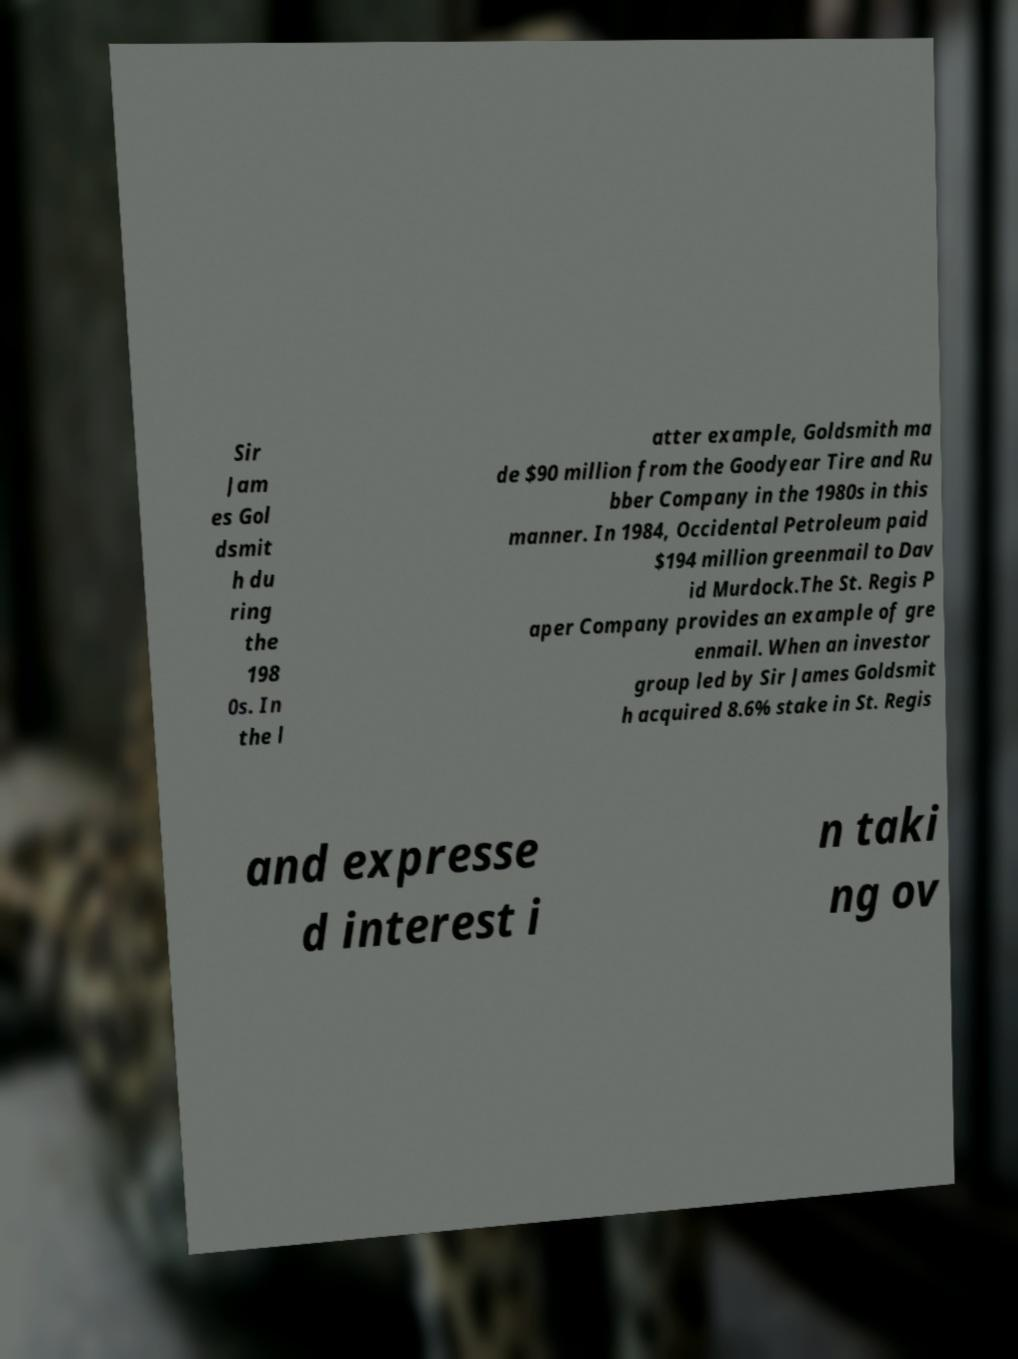Could you extract and type out the text from this image? Sir Jam es Gol dsmit h du ring the 198 0s. In the l atter example, Goldsmith ma de $90 million from the Goodyear Tire and Ru bber Company in the 1980s in this manner. In 1984, Occidental Petroleum paid $194 million greenmail to Dav id Murdock.The St. Regis P aper Company provides an example of gre enmail. When an investor group led by Sir James Goldsmit h acquired 8.6% stake in St. Regis and expresse d interest i n taki ng ov 